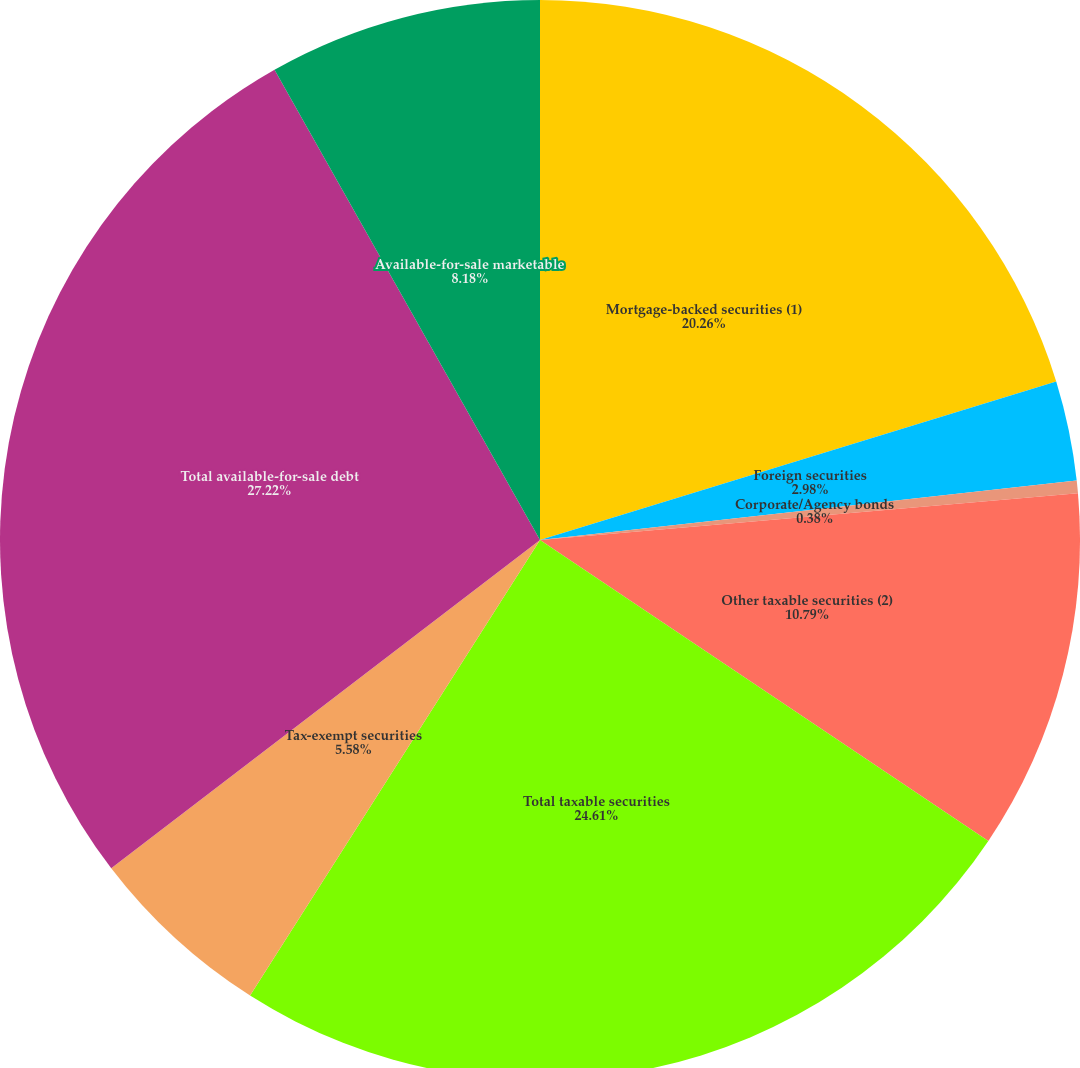Convert chart to OTSL. <chart><loc_0><loc_0><loc_500><loc_500><pie_chart><fcel>Mortgage-backed securities (1)<fcel>Foreign securities<fcel>Corporate/Agency bonds<fcel>Other taxable securities (2)<fcel>Total taxable securities<fcel>Tax-exempt securities<fcel>Total available-for-sale debt<fcel>Available-for-sale marketable<nl><fcel>20.26%<fcel>2.98%<fcel>0.38%<fcel>10.79%<fcel>24.61%<fcel>5.58%<fcel>27.22%<fcel>8.18%<nl></chart> 